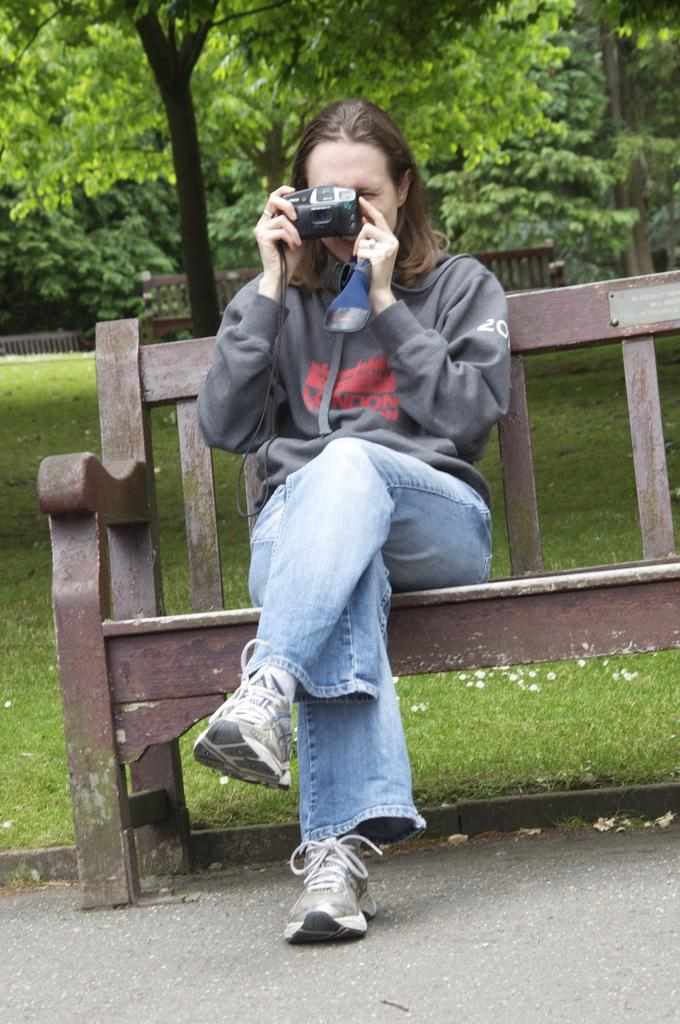What is the woman in the image doing? The woman is sitting on a bench in the image. What is the woman wearing? The woman is wearing a hoodie. What is the woman holding? The woman is holding a camera. What can be seen in the background of the image? There are additional benches and trees in the background of the image. What type of view can be seen through the camera lens in the image? There is no view visible through the camera lens in the image, as the camera is being held by the woman and not pointed at anything. 